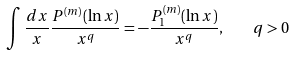<formula> <loc_0><loc_0><loc_500><loc_500>\int { \frac { d x } { x } } { \frac { P ^ { ( m ) } ( \ln x ) } { x ^ { q } } } = - { \frac { P _ { 1 } ^ { ( m ) } ( \ln x ) } { x ^ { q } } } , \quad q > 0</formula> 